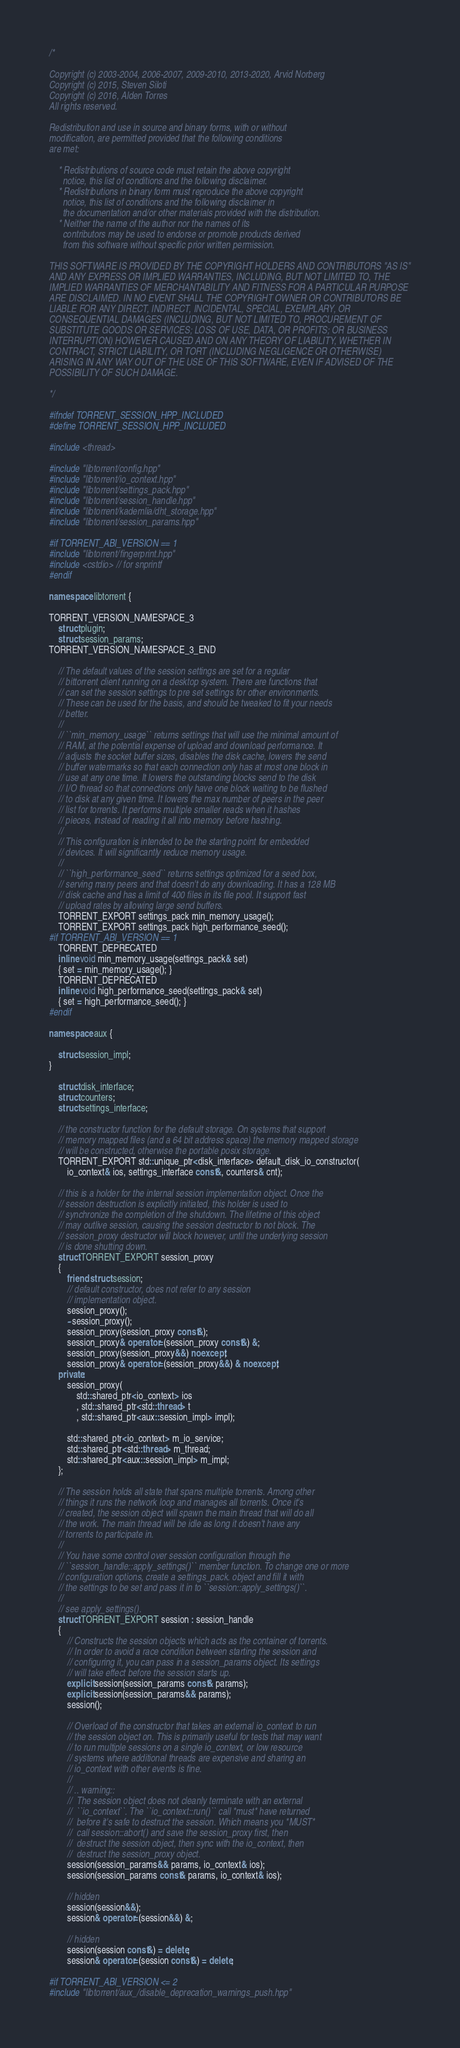<code> <loc_0><loc_0><loc_500><loc_500><_C++_>/*

Copyright (c) 2003-2004, 2006-2007, 2009-2010, 2013-2020, Arvid Norberg
Copyright (c) 2015, Steven Siloti
Copyright (c) 2016, Alden Torres
All rights reserved.

Redistribution and use in source and binary forms, with or without
modification, are permitted provided that the following conditions
are met:

    * Redistributions of source code must retain the above copyright
      notice, this list of conditions and the following disclaimer.
    * Redistributions in binary form must reproduce the above copyright
      notice, this list of conditions and the following disclaimer in
      the documentation and/or other materials provided with the distribution.
    * Neither the name of the author nor the names of its
      contributors may be used to endorse or promote products derived
      from this software without specific prior written permission.

THIS SOFTWARE IS PROVIDED BY THE COPYRIGHT HOLDERS AND CONTRIBUTORS "AS IS"
AND ANY EXPRESS OR IMPLIED WARRANTIES, INCLUDING, BUT NOT LIMITED TO, THE
IMPLIED WARRANTIES OF MERCHANTABILITY AND FITNESS FOR A PARTICULAR PURPOSE
ARE DISCLAIMED. IN NO EVENT SHALL THE COPYRIGHT OWNER OR CONTRIBUTORS BE
LIABLE FOR ANY DIRECT, INDIRECT, INCIDENTAL, SPECIAL, EXEMPLARY, OR
CONSEQUENTIAL DAMAGES (INCLUDING, BUT NOT LIMITED TO, PROCUREMENT OF
SUBSTITUTE GOODS OR SERVICES; LOSS OF USE, DATA, OR PROFITS; OR BUSINESS
INTERRUPTION) HOWEVER CAUSED AND ON ANY THEORY OF LIABILITY, WHETHER IN
CONTRACT, STRICT LIABILITY, OR TORT (INCLUDING NEGLIGENCE OR OTHERWISE)
ARISING IN ANY WAY OUT OF THE USE OF THIS SOFTWARE, EVEN IF ADVISED OF THE
POSSIBILITY OF SUCH DAMAGE.

*/

#ifndef TORRENT_SESSION_HPP_INCLUDED
#define TORRENT_SESSION_HPP_INCLUDED

#include <thread>

#include "libtorrent/config.hpp"
#include "libtorrent/io_context.hpp"
#include "libtorrent/settings_pack.hpp"
#include "libtorrent/session_handle.hpp"
#include "libtorrent/kademlia/dht_storage.hpp"
#include "libtorrent/session_params.hpp"

#if TORRENT_ABI_VERSION == 1
#include "libtorrent/fingerprint.hpp"
#include <cstdio> // for snprintf
#endif

namespace libtorrent {

TORRENT_VERSION_NAMESPACE_3
	struct plugin;
	struct session_params;
TORRENT_VERSION_NAMESPACE_3_END

	// The default values of the session settings are set for a regular
	// bittorrent client running on a desktop system. There are functions that
	// can set the session settings to pre set settings for other environments.
	// These can be used for the basis, and should be tweaked to fit your needs
	// better.
	//
	// ``min_memory_usage`` returns settings that will use the minimal amount of
	// RAM, at the potential expense of upload and download performance. It
	// adjusts the socket buffer sizes, disables the disk cache, lowers the send
	// buffer watermarks so that each connection only has at most one block in
	// use at any one time. It lowers the outstanding blocks send to the disk
	// I/O thread so that connections only have one block waiting to be flushed
	// to disk at any given time. It lowers the max number of peers in the peer
	// list for torrents. It performs multiple smaller reads when it hashes
	// pieces, instead of reading it all into memory before hashing.
	//
	// This configuration is intended to be the starting point for embedded
	// devices. It will significantly reduce memory usage.
	//
	// ``high_performance_seed`` returns settings optimized for a seed box,
	// serving many peers and that doesn't do any downloading. It has a 128 MB
	// disk cache and has a limit of 400 files in its file pool. It support fast
	// upload rates by allowing large send buffers.
	TORRENT_EXPORT settings_pack min_memory_usage();
	TORRENT_EXPORT settings_pack high_performance_seed();
#if TORRENT_ABI_VERSION == 1
	TORRENT_DEPRECATED
	inline void min_memory_usage(settings_pack& set)
	{ set = min_memory_usage(); }
	TORRENT_DEPRECATED
	inline void high_performance_seed(settings_pack& set)
	{ set = high_performance_seed(); }
#endif

namespace aux {

	struct session_impl;
}

	struct disk_interface;
	struct counters;
	struct settings_interface;

	// the constructor function for the default storage. On systems that support
	// memory mapped files (and a 64 bit address space) the memory mapped storage
	// will be constructed, otherwise the portable posix storage.
	TORRENT_EXPORT std::unique_ptr<disk_interface> default_disk_io_constructor(
		io_context& ios, settings_interface const&, counters& cnt);

	// this is a holder for the internal session implementation object. Once the
	// session destruction is explicitly initiated, this holder is used to
	// synchronize the completion of the shutdown. The lifetime of this object
	// may outlive session, causing the session destructor to not block. The
	// session_proxy destructor will block however, until the underlying session
	// is done shutting down.
	struct TORRENT_EXPORT session_proxy
	{
		friend struct session;
		// default constructor, does not refer to any session
		// implementation object.
		session_proxy();
		~session_proxy();
		session_proxy(session_proxy const&);
		session_proxy& operator=(session_proxy const&) &;
		session_proxy(session_proxy&&) noexcept;
		session_proxy& operator=(session_proxy&&) & noexcept;
	private:
		session_proxy(
			std::shared_ptr<io_context> ios
			, std::shared_ptr<std::thread> t
			, std::shared_ptr<aux::session_impl> impl);

		std::shared_ptr<io_context> m_io_service;
		std::shared_ptr<std::thread> m_thread;
		std::shared_ptr<aux::session_impl> m_impl;
	};

	// The session holds all state that spans multiple torrents. Among other
	// things it runs the network loop and manages all torrents. Once it's
	// created, the session object will spawn the main thread that will do all
	// the work. The main thread will be idle as long it doesn't have any
	// torrents to participate in.
	//
	// You have some control over session configuration through the
	// ``session_handle::apply_settings()`` member function. To change one or more
	// configuration options, create a settings_pack. object and fill it with
	// the settings to be set and pass it in to ``session::apply_settings()``.
	//
	// see apply_settings().
	struct TORRENT_EXPORT session : session_handle
	{
		// Constructs the session objects which acts as the container of torrents.
		// In order to avoid a race condition between starting the session and
		// configuring it, you can pass in a session_params object. Its settings
		// will take effect before the session starts up.
		explicit session(session_params const& params);
		explicit session(session_params&& params);
		session();

		// Overload of the constructor that takes an external io_context to run
		// the session object on. This is primarily useful for tests that may want
		// to run multiple sessions on a single io_context, or low resource
		// systems where additional threads are expensive and sharing an
		// io_context with other events is fine.
		//
		// .. warning::
		// 	The session object does not cleanly terminate with an external
		// 	``io_context``. The ``io_context::run()`` call *must* have returned
		// 	before it's safe to destruct the session. Which means you *MUST*
		// 	call session::abort() and save the session_proxy first, then
		// 	destruct the session object, then sync with the io_context, then
		// 	destruct the session_proxy object.
		session(session_params&& params, io_context& ios);
		session(session_params const& params, io_context& ios);

		// hidden
		session(session&&);
		session& operator=(session&&) &;

		// hidden
		session(session const&) = delete;
		session& operator=(session const&) = delete;

#if TORRENT_ABI_VERSION <= 2
#include "libtorrent/aux_/disable_deprecation_warnings_push.hpp"
</code> 